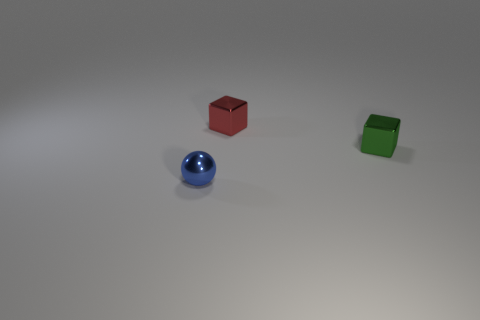Add 2 red blocks. How many objects exist? 5 Subtract all cubes. How many objects are left? 1 Add 1 green things. How many green things exist? 2 Subtract 0 brown blocks. How many objects are left? 3 Subtract all big gray matte balls. Subtract all tiny green shiny objects. How many objects are left? 2 Add 2 blocks. How many blocks are left? 4 